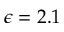Convert formula to latex. <formula><loc_0><loc_0><loc_500><loc_500>\epsilon = 2 . 1</formula> 